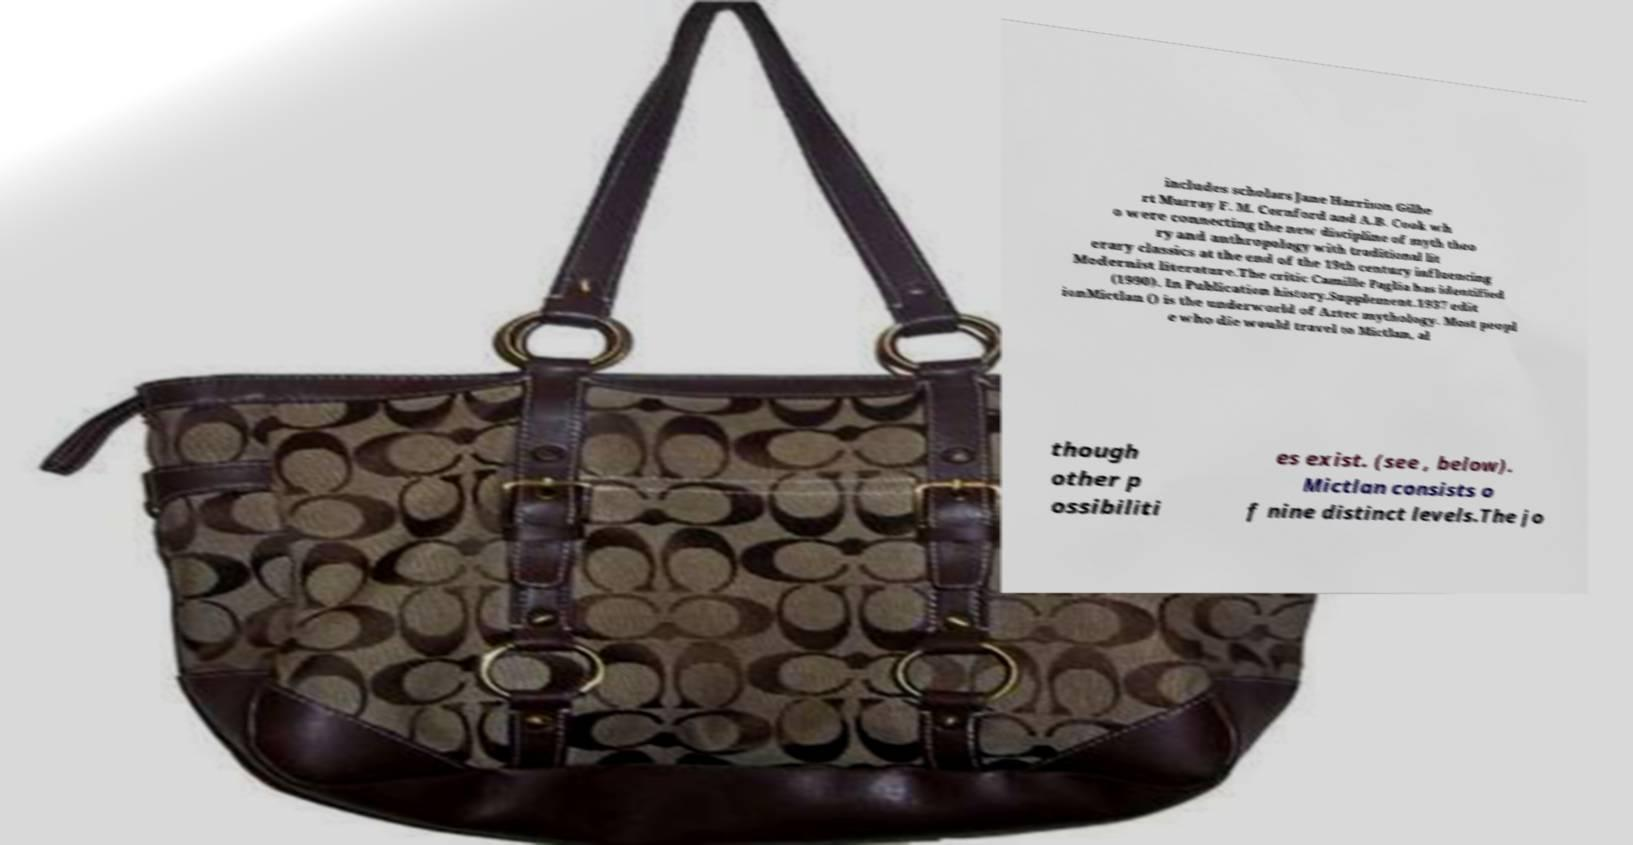Could you extract and type out the text from this image? includes scholars Jane Harrison Gilbe rt Murray F. M. Cornford and A.B. Cook wh o were connecting the new discipline of myth theo ry and anthropology with traditional lit erary classics at the end of the 19th century influencing Modernist literature.The critic Camille Paglia has identified (1990). In Publication history.Supplement.1937 edit ionMictlan () is the underworld of Aztec mythology. Most peopl e who die would travel to Mictlan, al though other p ossibiliti es exist. (see , below). Mictlan consists o f nine distinct levels.The jo 